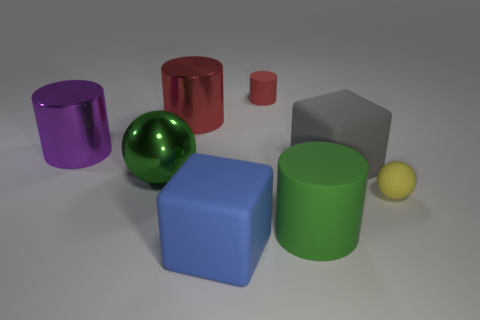Add 2 large balls. How many objects exist? 10 Subtract all gray cylinders. Subtract all red balls. How many cylinders are left? 4 Subtract all blocks. How many objects are left? 6 Add 3 big gray rubber objects. How many big gray rubber objects are left? 4 Add 5 yellow matte spheres. How many yellow matte spheres exist? 6 Subtract 0 purple cubes. How many objects are left? 8 Subtract all small blue cylinders. Subtract all tiny matte balls. How many objects are left? 7 